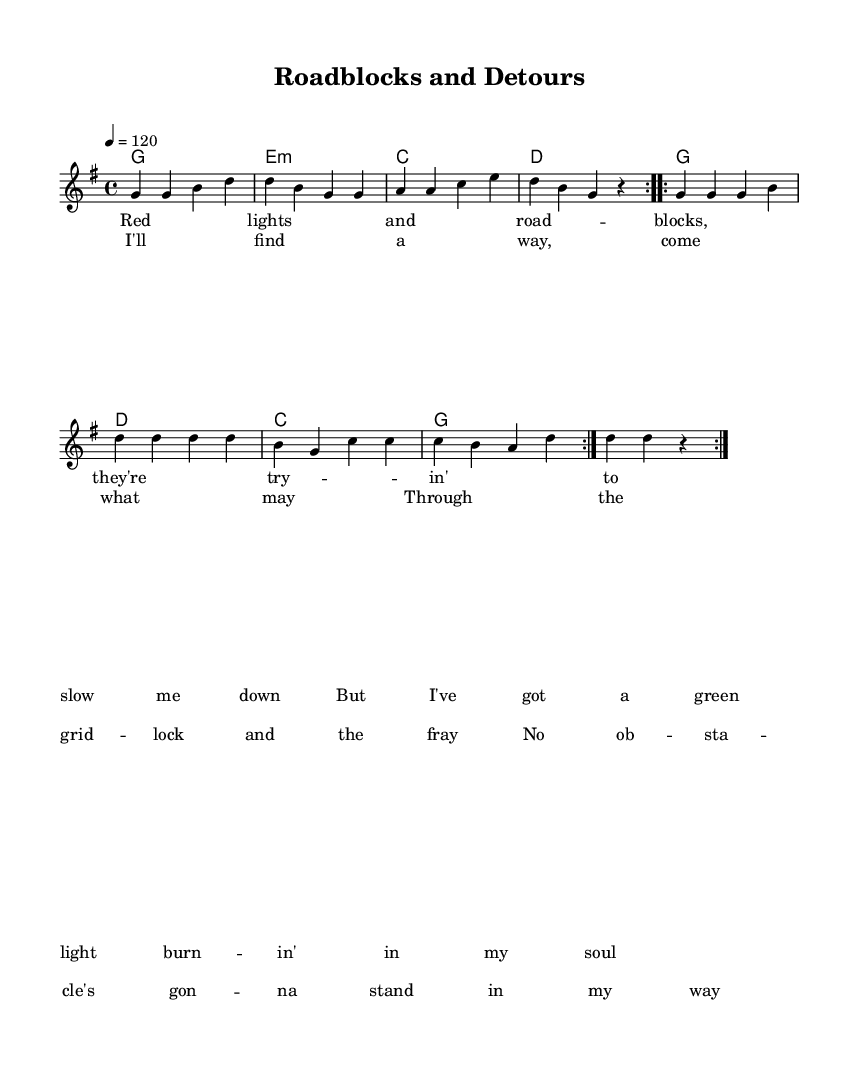What is the key signature of this music? The key signature is G major, which has one sharp (F#). This can be identified at the beginning of the sheet music where the key signature is indicated.
Answer: G major What is the time signature of the piece? The time signature is 4/4, meaning there are four beats in each measure and the quarter note receives one beat. This is located at the beginning of the score.
Answer: 4/4 What is the tempo marking given in the score? The tempo marking indicates 120 beats per minute, set at a quarter note equals 120. This is shown at the beginning of the music score.
Answer: 120 What is the musical form of the piece? The piece features a structure of repeated verses and choruses. Analyzing the "verse" and "chorus" labels and their respective repetitions indicates this form.
Answer: Verse-Chorus Which chords are used in the first section of the music? The first section uses the chords G, E minor, C, and D, which are indicated in the chord names beneath the melody.
Answer: G, E minor, C, D What is the theme of the lyrics in this piece? The lyrics focus on perseverance and overcoming obstacles, as highlighted in phrases such as "no obstacle’s gonna stand in my way." This theme is common in country music as reflected in the lyrical content.
Answer: Perseverance How many verses are repeated in the melody? The melody has two verses indicated by the "repeat volta 2" instruction, showing that the verses are to be played two times.
Answer: Two 